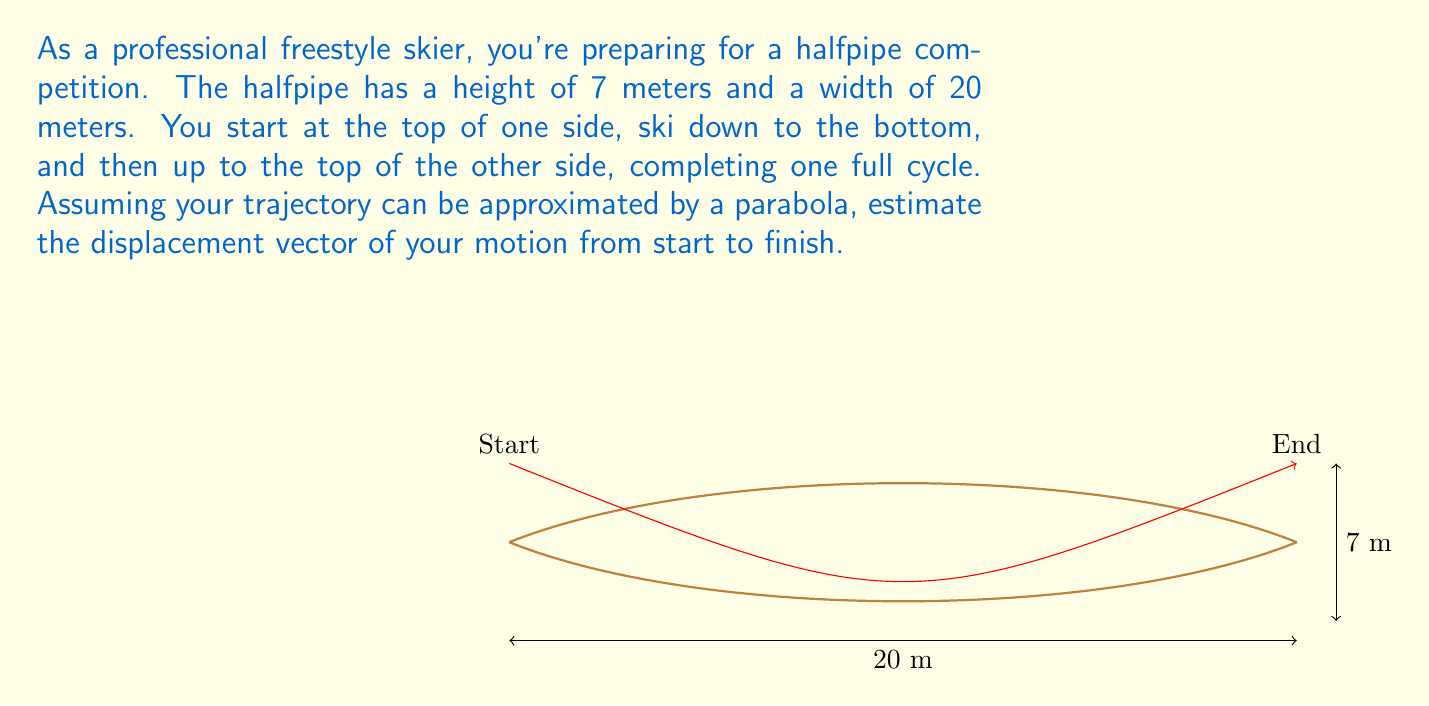Teach me how to tackle this problem. To estimate the displacement vector, we need to determine the horizontal and vertical components of the skier's motion from start to finish. Let's break this down step-by-step:

1) The horizontal component is straightforward:
   - The skier moves from one side of the halfpipe to the other.
   - The width of the halfpipe is 20 meters.
   - Therefore, the horizontal displacement is 20 meters to the right.

2) The vertical component is zero:
   - The skier starts at the top of one side and ends at the top of the other side.
   - Both points are at the same height (7 meters above the bottom of the halfpipe).
   - Therefore, there is no net vertical displacement.

3) We can represent this displacement as a vector:
   $$\vec{d} = 20\hat{i} + 0\hat{j}$$
   Where $\hat{i}$ is the unit vector in the horizontal direction and $\hat{j}$ is the unit vector in the vertical direction.

4) The magnitude of this displacement vector is:
   $$|\vec{d}| = \sqrt{20^2 + 0^2} = 20 \text{ meters}$$

5) The direction of the displacement is purely horizontal (to the right), which corresponds to an angle of 0° with respect to the positive x-axis.

Therefore, the displacement vector can be expressed as 20 meters in the positive x-direction (horizontally to the right).
Answer: $\vec{d} = 20\hat{i} \text{ meters}$ 